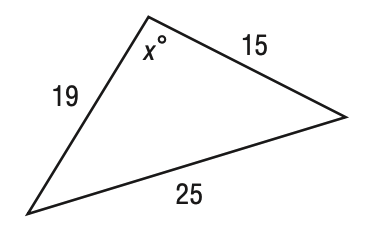Answer the mathemtical geometry problem and directly provide the correct option letter.
Question: Find x in the figure below. Round your answer to the nearest tenth if necessary.
Choices: A: 91.9 B: 93.9 C: 95.9 D: 97.9 B 